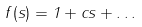Convert formula to latex. <formula><loc_0><loc_0><loc_500><loc_500>f ( s ) = 1 + c s + \dots</formula> 